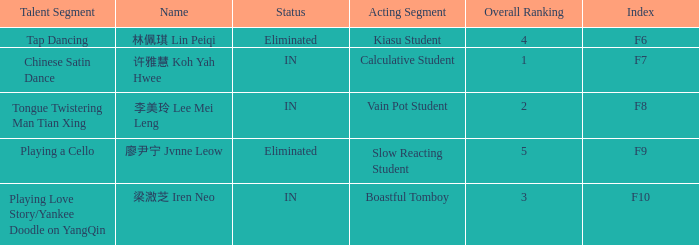For the event with index f7, what is the status? IN. 